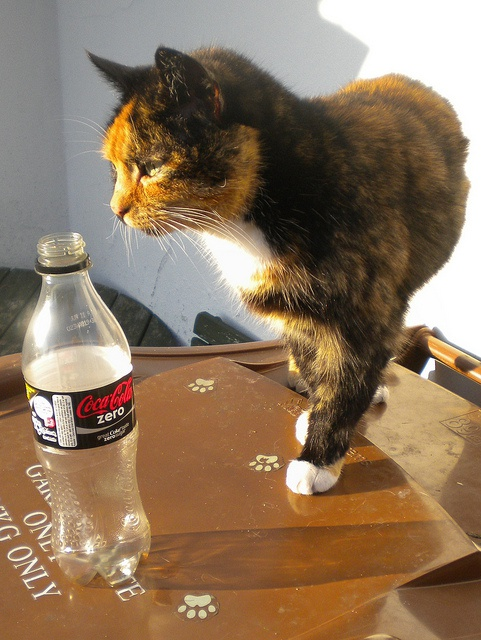Describe the objects in this image and their specific colors. I can see cat in gray, black, and maroon tones and bottle in gray, tan, ivory, and darkgray tones in this image. 